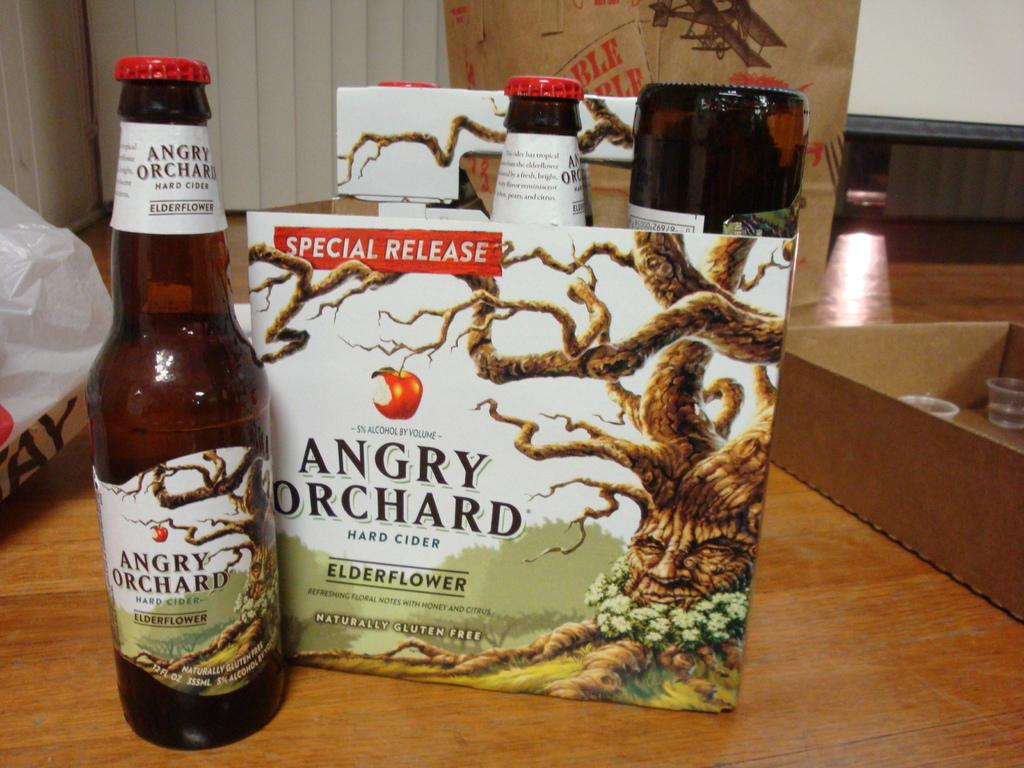Provide a one-sentence caption for the provided image. A carton of bottles from Angry Orchard sit on wooden table. 